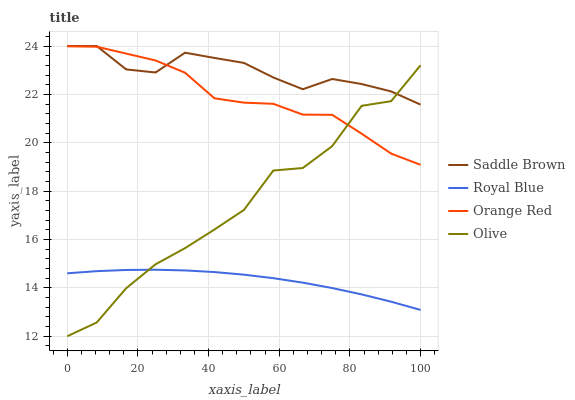Does Royal Blue have the minimum area under the curve?
Answer yes or no. Yes. Does Saddle Brown have the maximum area under the curve?
Answer yes or no. Yes. Does Saddle Brown have the minimum area under the curve?
Answer yes or no. No. Does Royal Blue have the maximum area under the curve?
Answer yes or no. No. Is Royal Blue the smoothest?
Answer yes or no. Yes. Is Olive the roughest?
Answer yes or no. Yes. Is Saddle Brown the smoothest?
Answer yes or no. No. Is Saddle Brown the roughest?
Answer yes or no. No. Does Olive have the lowest value?
Answer yes or no. Yes. Does Royal Blue have the lowest value?
Answer yes or no. No. Does Saddle Brown have the highest value?
Answer yes or no. Yes. Does Royal Blue have the highest value?
Answer yes or no. No. Is Royal Blue less than Orange Red?
Answer yes or no. Yes. Is Orange Red greater than Royal Blue?
Answer yes or no. Yes. Does Orange Red intersect Saddle Brown?
Answer yes or no. Yes. Is Orange Red less than Saddle Brown?
Answer yes or no. No. Is Orange Red greater than Saddle Brown?
Answer yes or no. No. Does Royal Blue intersect Orange Red?
Answer yes or no. No. 